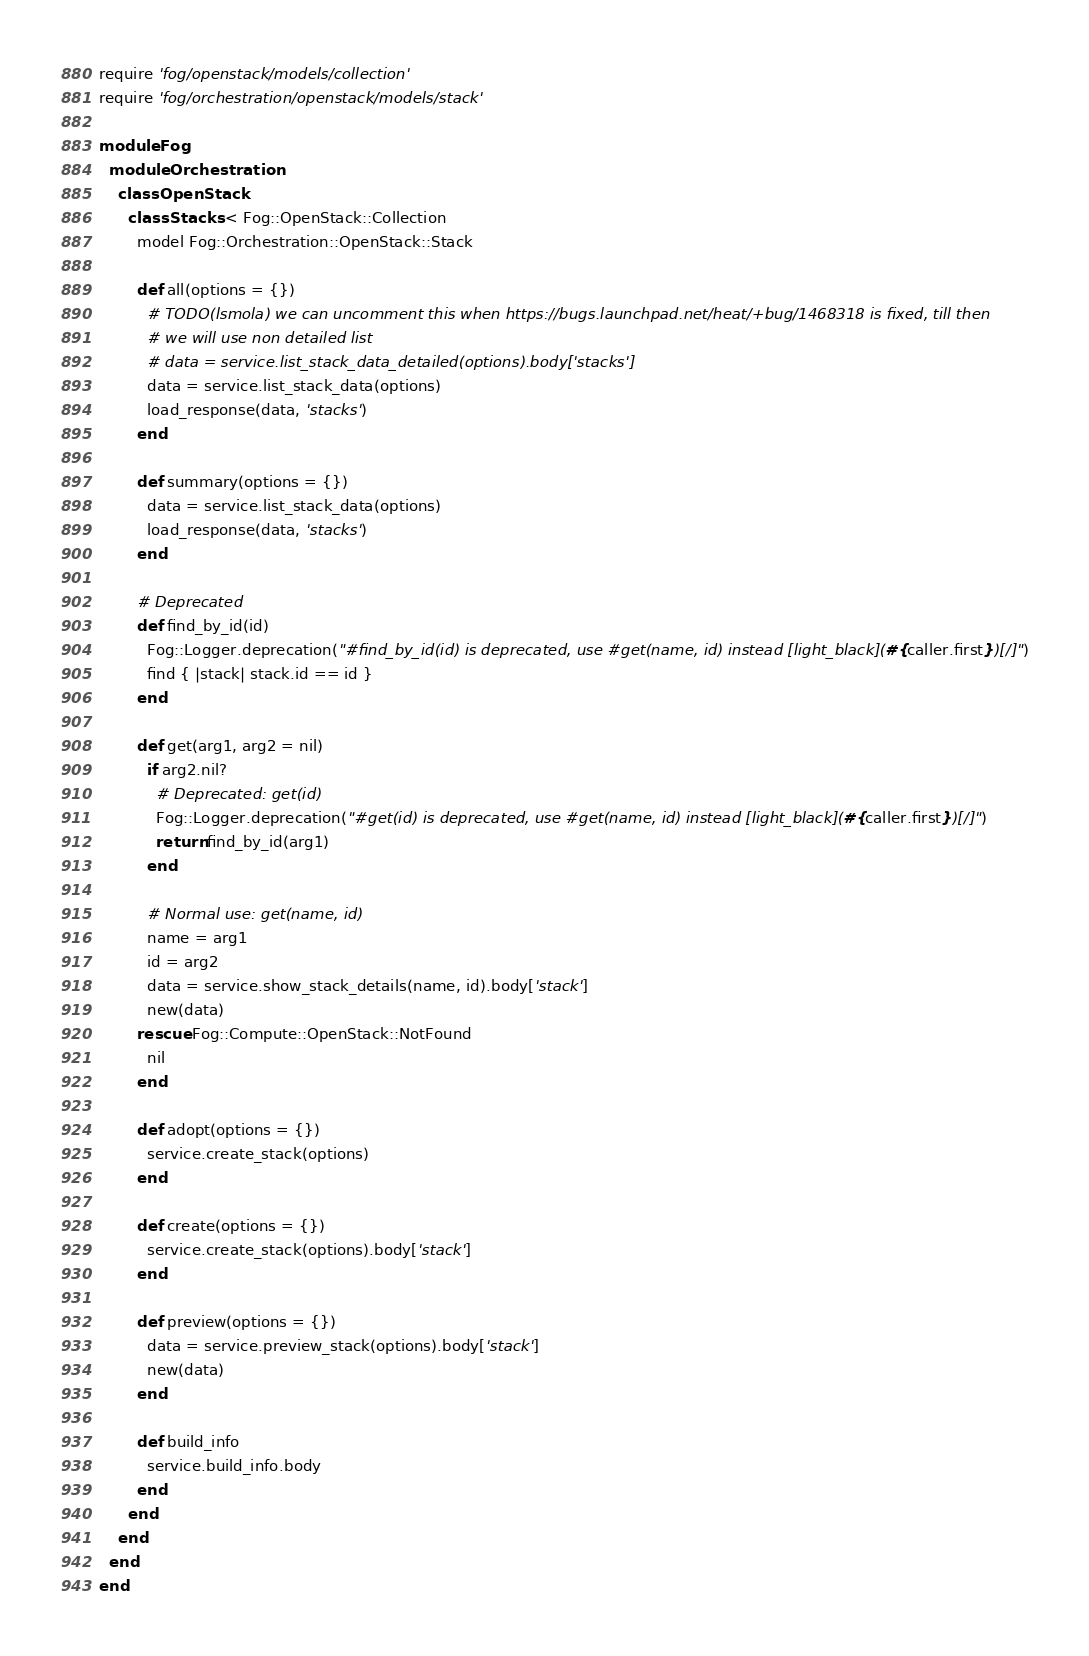Convert code to text. <code><loc_0><loc_0><loc_500><loc_500><_Ruby_>require 'fog/openstack/models/collection'
require 'fog/orchestration/openstack/models/stack'

module Fog
  module Orchestration
    class OpenStack
      class Stacks < Fog::OpenStack::Collection
        model Fog::Orchestration::OpenStack::Stack

        def all(options = {})
          # TODO(lsmola) we can uncomment this when https://bugs.launchpad.net/heat/+bug/1468318 is fixed, till then
          # we will use non detailed list
          # data = service.list_stack_data_detailed(options).body['stacks']
          data = service.list_stack_data(options)
          load_response(data, 'stacks')
        end

        def summary(options = {})
          data = service.list_stack_data(options)
          load_response(data, 'stacks')
        end

        # Deprecated
        def find_by_id(id)
          Fog::Logger.deprecation("#find_by_id(id) is deprecated, use #get(name, id) instead [light_black](#{caller.first})[/]")
          find { |stack| stack.id == id }
        end

        def get(arg1, arg2 = nil)
          if arg2.nil?
            # Deprecated: get(id)
            Fog::Logger.deprecation("#get(id) is deprecated, use #get(name, id) instead [light_black](#{caller.first})[/]")
            return find_by_id(arg1)
          end

          # Normal use: get(name, id)
          name = arg1
          id = arg2
          data = service.show_stack_details(name, id).body['stack']
          new(data)
        rescue Fog::Compute::OpenStack::NotFound
          nil
        end

        def adopt(options = {})
          service.create_stack(options)
        end

        def create(options = {})
          service.create_stack(options).body['stack']
        end

        def preview(options = {})
          data = service.preview_stack(options).body['stack']
          new(data)
        end

        def build_info
          service.build_info.body
        end
      end
    end
  end
end
</code> 